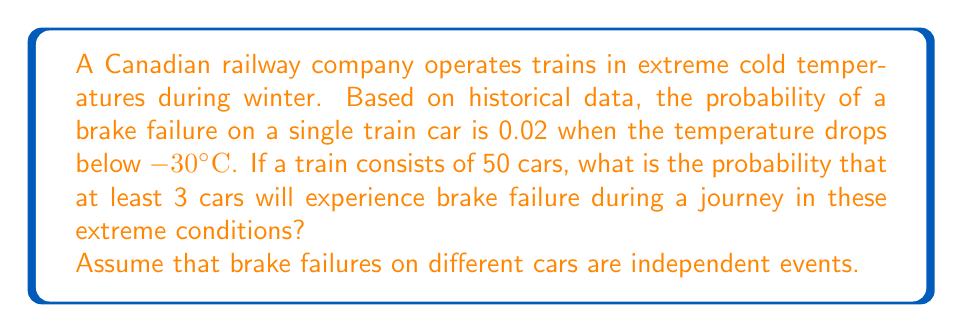Teach me how to tackle this problem. Let's approach this step-by-step using the binomial distribution:

1) Let X be the random variable representing the number of cars with brake failure.

2) We have:
   n = 50 (number of cars)
   p = 0.02 (probability of failure for each car)
   We want P(X ≥ 3)

3) Instead of calculating P(X ≥ 3) directly, it's easier to calculate 1 - P(X < 3):
   P(X ≥ 3) = 1 - P(X < 3) = 1 - [P(X = 0) + P(X = 1) + P(X = 2)]

4) Using the binomial probability formula:
   $$P(X = k) = \binom{n}{k} p^k (1-p)^{n-k}$$

5) Calculate each probability:
   P(X = 0) = $\binom{50}{0} (0.02)^0 (0.98)^{50} = 0.3641$
   P(X = 1) = $\binom{50}{1} (0.02)^1 (0.98)^{49} = 0.3707$
   P(X = 2) = $\binom{50}{2} (0.02)^2 (0.98)^{48} = 0.1853$

6) Sum these probabilities:
   P(X < 3) = 0.3641 + 0.3707 + 0.1853 = 0.9201

7) Therefore:
   P(X ≥ 3) = 1 - 0.9201 = 0.0799
Answer: 0.0799 